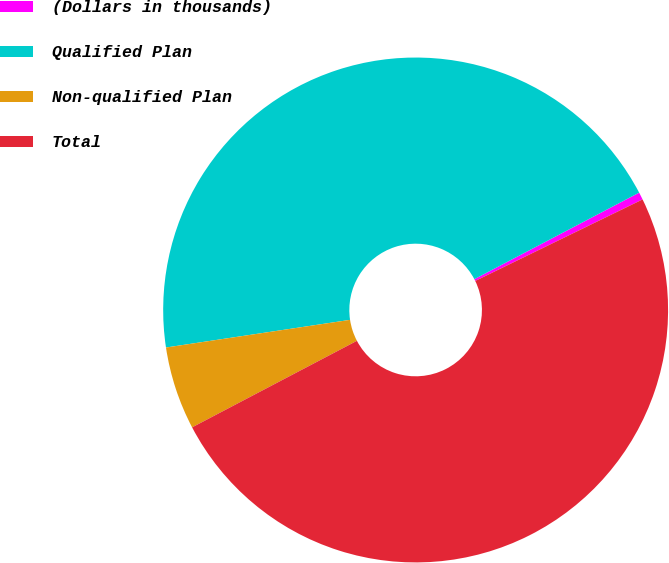Convert chart to OTSL. <chart><loc_0><loc_0><loc_500><loc_500><pie_chart><fcel>(Dollars in thousands)<fcel>Qualified Plan<fcel>Non-qualified Plan<fcel>Total<nl><fcel>0.48%<fcel>44.68%<fcel>5.32%<fcel>49.52%<nl></chart> 